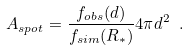Convert formula to latex. <formula><loc_0><loc_0><loc_500><loc_500>A _ { s p o t } = \frac { f _ { o b s } ( d ) } { f _ { s i m } ( R _ { * } ) } 4 \pi d ^ { 2 } \ .</formula> 